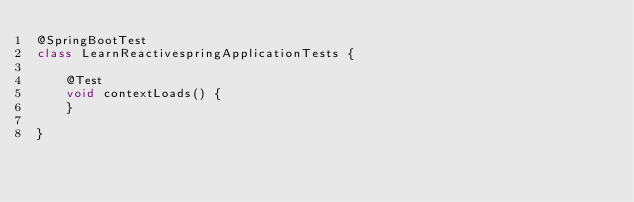Convert code to text. <code><loc_0><loc_0><loc_500><loc_500><_Java_>@SpringBootTest
class LearnReactivespringApplicationTests {

	@Test
	void contextLoads() {
	}

}
</code> 